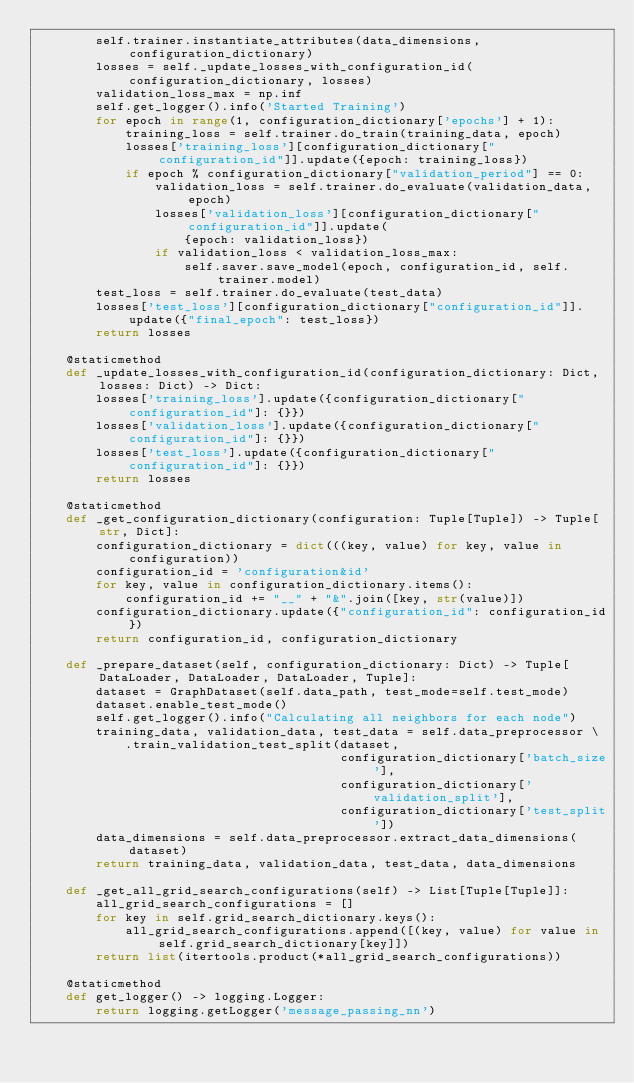Convert code to text. <code><loc_0><loc_0><loc_500><loc_500><_Python_>        self.trainer.instantiate_attributes(data_dimensions, configuration_dictionary)
        losses = self._update_losses_with_configuration_id(configuration_dictionary, losses)
        validation_loss_max = np.inf
        self.get_logger().info('Started Training')
        for epoch in range(1, configuration_dictionary['epochs'] + 1):
            training_loss = self.trainer.do_train(training_data, epoch)
            losses['training_loss'][configuration_dictionary["configuration_id"]].update({epoch: training_loss})
            if epoch % configuration_dictionary["validation_period"] == 0:
                validation_loss = self.trainer.do_evaluate(validation_data, epoch)
                losses['validation_loss'][configuration_dictionary["configuration_id"]].update(
                    {epoch: validation_loss})
                if validation_loss < validation_loss_max:
                    self.saver.save_model(epoch, configuration_id, self.trainer.model)
        test_loss = self.trainer.do_evaluate(test_data)
        losses['test_loss'][configuration_dictionary["configuration_id"]].update({"final_epoch": test_loss})
        return losses

    @staticmethod
    def _update_losses_with_configuration_id(configuration_dictionary: Dict, losses: Dict) -> Dict:
        losses['training_loss'].update({configuration_dictionary["configuration_id"]: {}})
        losses['validation_loss'].update({configuration_dictionary["configuration_id"]: {}})
        losses['test_loss'].update({configuration_dictionary["configuration_id"]: {}})
        return losses

    @staticmethod
    def _get_configuration_dictionary(configuration: Tuple[Tuple]) -> Tuple[str, Dict]:
        configuration_dictionary = dict(((key, value) for key, value in configuration))
        configuration_id = 'configuration&id'
        for key, value in configuration_dictionary.items():
            configuration_id += "__" + "&".join([key, str(value)])
        configuration_dictionary.update({"configuration_id": configuration_id})
        return configuration_id, configuration_dictionary

    def _prepare_dataset(self, configuration_dictionary: Dict) -> Tuple[DataLoader, DataLoader, DataLoader, Tuple]:
        dataset = GraphDataset(self.data_path, test_mode=self.test_mode)
        dataset.enable_test_mode()
        self.get_logger().info("Calculating all neighbors for each node")
        training_data, validation_data, test_data = self.data_preprocessor \
            .train_validation_test_split(dataset,
                                         configuration_dictionary['batch_size'],
                                         configuration_dictionary['validation_split'],
                                         configuration_dictionary['test_split'])
        data_dimensions = self.data_preprocessor.extract_data_dimensions(dataset)
        return training_data, validation_data, test_data, data_dimensions

    def _get_all_grid_search_configurations(self) -> List[Tuple[Tuple]]:
        all_grid_search_configurations = []
        for key in self.grid_search_dictionary.keys():
            all_grid_search_configurations.append([(key, value) for value in self.grid_search_dictionary[key]])
        return list(itertools.product(*all_grid_search_configurations))

    @staticmethod
    def get_logger() -> logging.Logger:
        return logging.getLogger('message_passing_nn')
</code> 